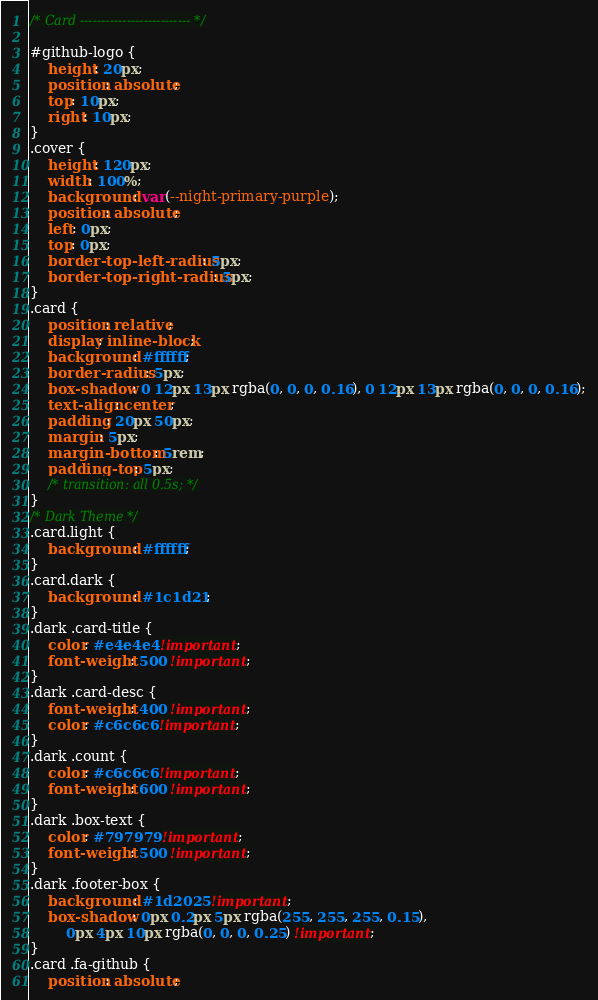<code> <loc_0><loc_0><loc_500><loc_500><_CSS_>/* Card -------------------------- */

#github-logo {
    height: 20px;
    position: absolute;
    top: 10px;
    right: 10px;
}
.cover {
    height: 120px;
    width: 100%;
    background: var(--night-primary-purple);
    position: absolute;
    left: 0px;
    top: 0px;
    border-top-left-radius: 5px;
    border-top-right-radius: 5px;
}
.card {
    position: relative;
    display: inline-block;
    background: #ffffff;
    border-radius: 5px;
    box-shadow: 0 12px 13px rgba(0, 0, 0, 0.16), 0 12px 13px rgba(0, 0, 0, 0.16);
    text-align: center;
    padding: 20px 50px;
    margin: 5px;
    margin-bottom: 5rem;
    padding-top: 5px;
    /* transition: all 0.5s; */
}
/* Dark Theme */
.card.light {
    background: #ffffff;
}
.card.dark {
    background: #1c1d21;
}
.dark .card-title {
    color: #e4e4e4 !important;
    font-weight: 500 !important;
}
.dark .card-desc {
    font-weight: 400 !important;
    color: #c6c6c6 !important;
}
.dark .count {
    color: #c6c6c6 !important;
    font-weight: 600 !important;
}
.dark .box-text {
    color: #797979 !important;
    font-weight: 500 !important;
}
.dark .footer-box {
    background: #1d2025 !important;
    box-shadow: 0px 0.2px 5px rgba(255, 255, 255, 0.15),
        0px 4px 10px rgba(0, 0, 0, 0.25) !important;
}
.card .fa-github {
    position: absolute;</code> 